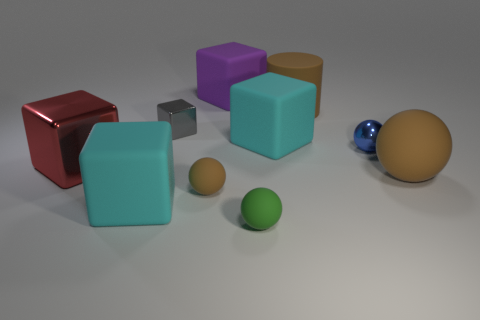Subtract all small brown balls. How many balls are left? 3 Subtract all blue balls. How many balls are left? 3 Subtract all cylinders. How many objects are left? 9 Subtract 2 spheres. How many spheres are left? 2 Subtract all brown balls. Subtract all brown spheres. How many objects are left? 6 Add 3 gray objects. How many gray objects are left? 4 Add 8 tiny purple metal things. How many tiny purple metal things exist? 8 Subtract 0 cyan cylinders. How many objects are left? 10 Subtract all yellow spheres. Subtract all yellow cylinders. How many spheres are left? 4 Subtract all yellow cylinders. How many red cubes are left? 1 